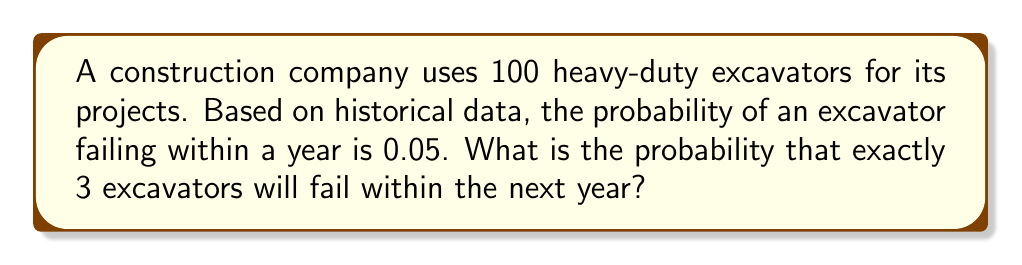Provide a solution to this math problem. This problem can be solved using the Binomial probability distribution:

1. Identify the parameters:
   - $n = 100$ (number of excavators)
   - $p = 0.05$ (probability of failure for each excavator)
   - $k = 3$ (number of excavators we want to fail)

2. The probability mass function for the Binomial distribution is:

   $$ P(X = k) = \binom{n}{k} p^k (1-p)^{n-k} $$

3. Calculate the binomial coefficient:

   $$ \binom{100}{3} = \frac{100!}{3!(100-3)!} = \frac{100!}{3!97!} = 161,700 $$

4. Substitute the values into the formula:

   $$ P(X = 3) = 161,700 \cdot (0.05)^3 \cdot (1-0.05)^{100-3} $$

5. Simplify:

   $$ P(X = 3) = 161,700 \cdot (0.000125) \cdot (0.95)^{97} $$
   $$ P(X = 3) = 20.2125 \cdot (0.95)^{97} $$
   $$ P(X = 3) = 20.2125 \cdot 0.0066 $$
   $$ P(X = 3) \approx 0.1334 $$

Therefore, the probability of exactly 3 excavators failing within the next year is approximately 0.1334 or 13.34%.
Answer: 0.1334 